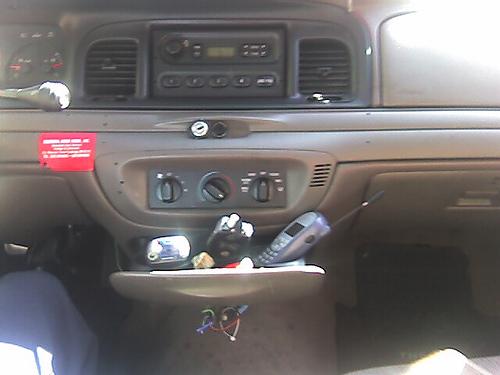Are the vents pointed in the same direction?
Answer briefly. No. Is the cellphone in the ashtray a smartphone?
Keep it brief. No. What is under the dash, in what looks like the ashtray?
Give a very brief answer. Phone. 